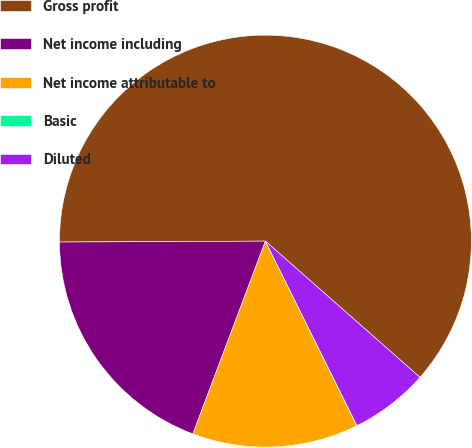Convert chart to OTSL. <chart><loc_0><loc_0><loc_500><loc_500><pie_chart><fcel>Gross profit<fcel>Net income including<fcel>Net income attributable to<fcel>Basic<fcel>Diluted<nl><fcel>61.57%<fcel>19.2%<fcel>13.05%<fcel>0.01%<fcel>6.17%<nl></chart> 